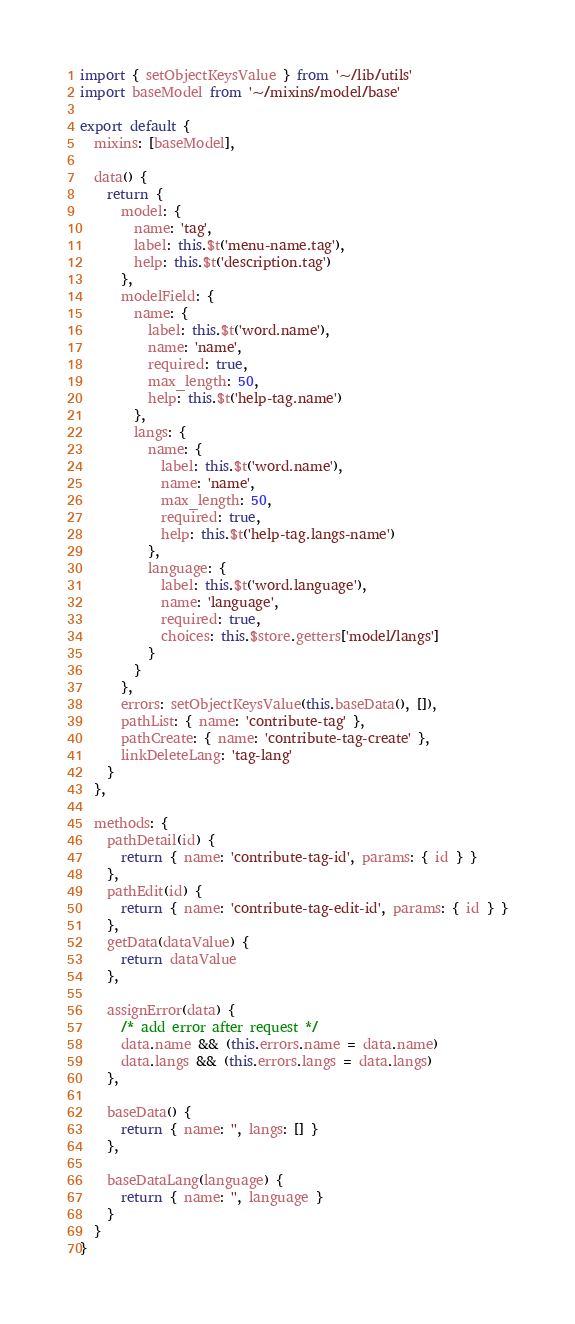<code> <loc_0><loc_0><loc_500><loc_500><_JavaScript_>import { setObjectKeysValue } from '~/lib/utils'
import baseModel from '~/mixins/model/base'

export default {
  mixins: [baseModel],

  data() {
    return {
      model: {
        name: 'tag',
        label: this.$t('menu-name.tag'),
        help: this.$t('description.tag')
      },
      modelField: {
        name: {
          label: this.$t('word.name'),
          name: 'name',
          required: true,
          max_length: 50,
          help: this.$t('help-tag.name')
        },
        langs: {
          name: {
            label: this.$t('word.name'),
            name: 'name',
            max_length: 50,
            required: true,
            help: this.$t('help-tag.langs-name')
          },
          language: {
            label: this.$t('word.language'),
            name: 'language',
            required: true,
            choices: this.$store.getters['model/langs']
          }
        }
      },
      errors: setObjectKeysValue(this.baseData(), []),
      pathList: { name: 'contribute-tag' },
      pathCreate: { name: 'contribute-tag-create' },
      linkDeleteLang: 'tag-lang'
    }
  },

  methods: {
    pathDetail(id) {
      return { name: 'contribute-tag-id', params: { id } }
    },
    pathEdit(id) {
      return { name: 'contribute-tag-edit-id', params: { id } }
    },
    getData(dataValue) {
      return dataValue
    },

    assignError(data) {
      /* add error after request */
      data.name && (this.errors.name = data.name)
      data.langs && (this.errors.langs = data.langs)
    },

    baseData() {
      return { name: '', langs: [] }
    },

    baseDataLang(language) {
      return { name: '', language }
    }
  }
}
</code> 